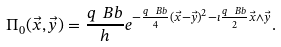<formula> <loc_0><loc_0><loc_500><loc_500>\Pi _ { 0 } ( \vec { x } , \vec { y } ) = \frac { q \ B b } { h } e ^ { - \frac { q \ B b } { 4 } ( \vec { x } - \vec { y } ) ^ { 2 } - \imath \frac { q \ B b } { 2 } \vec { x } \wedge \vec { y } } .</formula> 